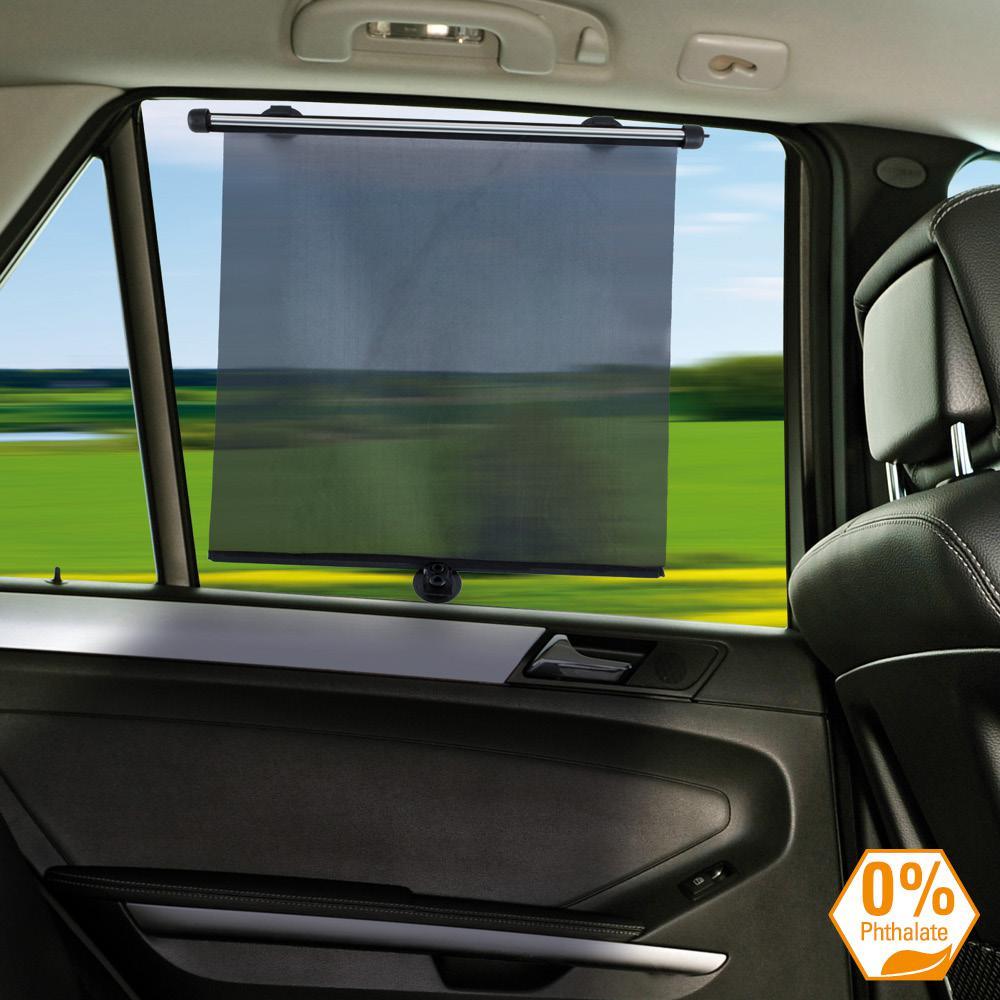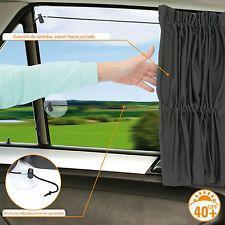The first image is the image on the left, the second image is the image on the right. For the images shown, is this caption "An image shows a car window fitted with a squarish gray shade with nonrounded corners." true? Answer yes or no. Yes. 